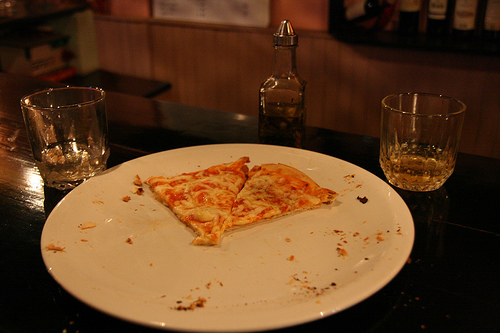Does that plate look white and rectangular? No, the plate is not rectangular but round, and it is white, providing a simple background for the pizza slices. 